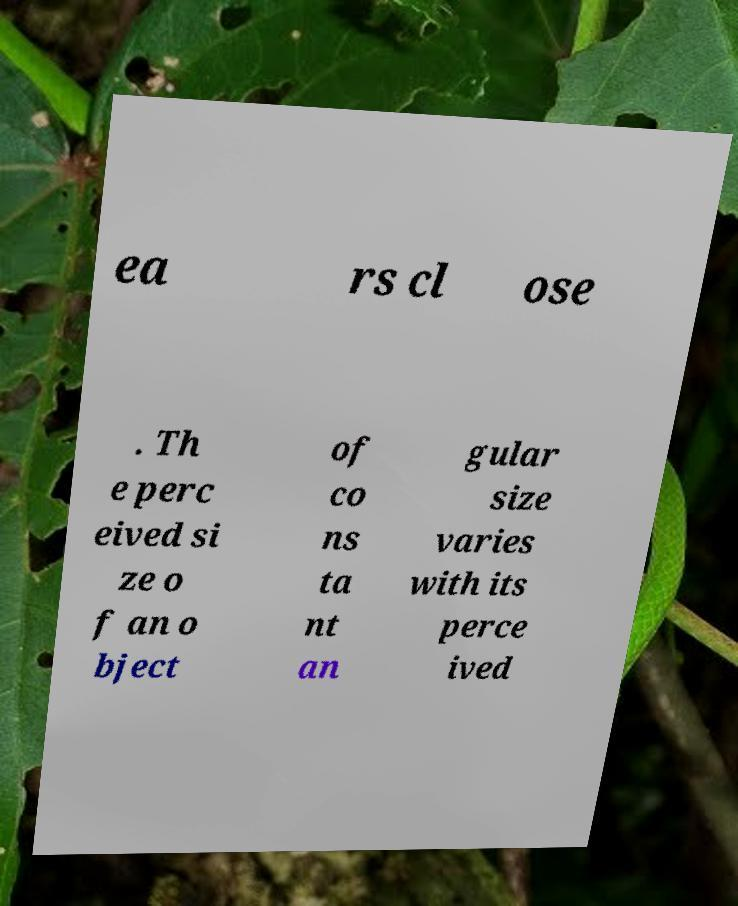Could you extract and type out the text from this image? ea rs cl ose . Th e perc eived si ze o f an o bject of co ns ta nt an gular size varies with its perce ived 